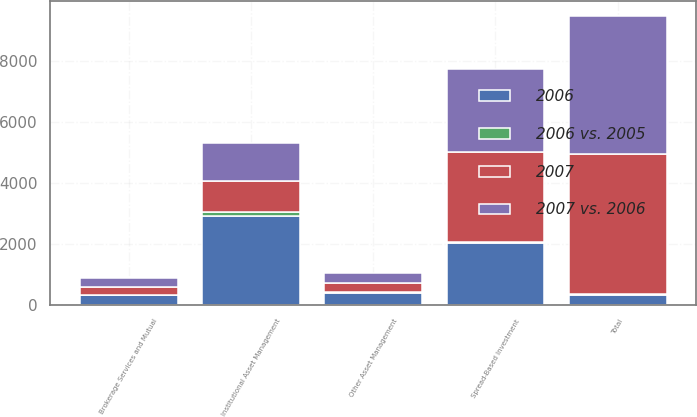Convert chart to OTSL. <chart><loc_0><loc_0><loc_500><loc_500><stacked_bar_chart><ecel><fcel>Spread-Based Investment<fcel>Institutional Asset Management<fcel>Brokerage Services and Mutual<fcel>Other Asset Management<fcel>Total<nl><fcel>2006<fcel>2023<fcel>2900<fcel>322<fcel>380<fcel>326<nl><fcel>2007 vs. 2006<fcel>2713<fcel>1240<fcel>293<fcel>297<fcel>4543<nl><fcel>2007<fcel>2973<fcel>1026<fcel>257<fcel>326<fcel>4582<nl><fcel>2006 vs. 2005<fcel>25<fcel>134<fcel>10<fcel>28<fcel>24<nl></chart> 